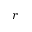<formula> <loc_0><loc_0><loc_500><loc_500>r</formula> 